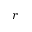<formula> <loc_0><loc_0><loc_500><loc_500>r</formula> 